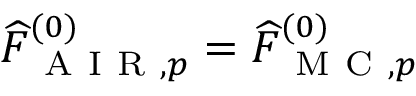<formula> <loc_0><loc_0><loc_500><loc_500>\widehat { F } _ { A I R , p } ^ { ( 0 ) } = \widehat { F } _ { M C , p } ^ { ( 0 ) }</formula> 